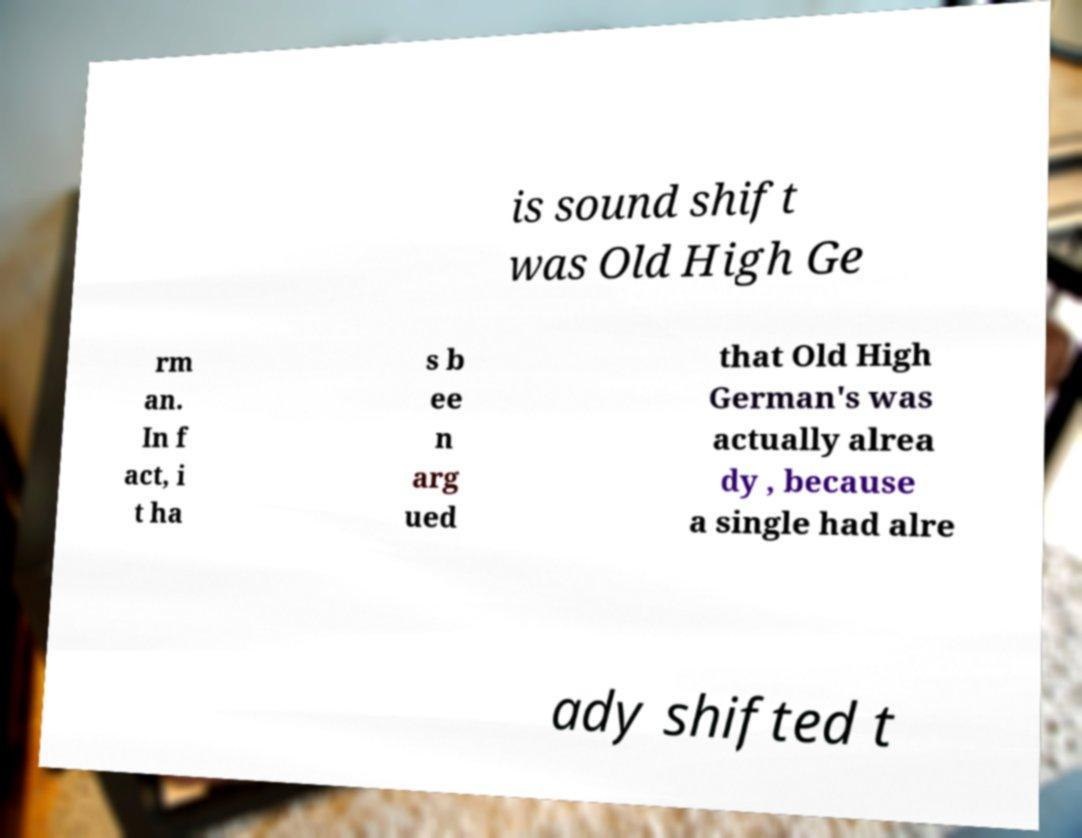Could you extract and type out the text from this image? is sound shift was Old High Ge rm an. In f act, i t ha s b ee n arg ued that Old High German's was actually alrea dy , because a single had alre ady shifted t 